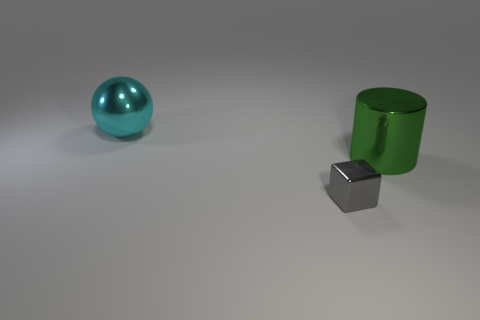How would you describe the lighting and shadows in the scene? The lighting in the scene appears to be coming from the upper left, casting subtle shadows to the right of each object. The shadows are soft and diffuse, suggesting the light source is not extremely close to the objects, possibly emulating overcast daylight or a soft indoor light. 